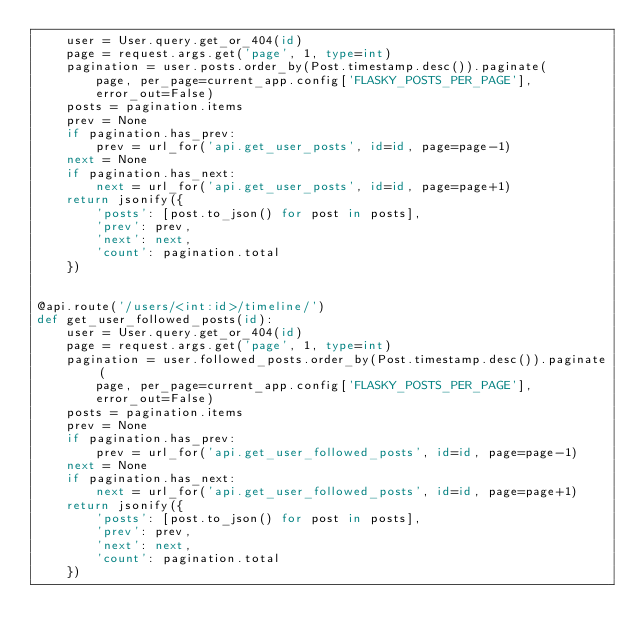<code> <loc_0><loc_0><loc_500><loc_500><_Python_>    user = User.query.get_or_404(id)
    page = request.args.get('page', 1, type=int)
    pagination = user.posts.order_by(Post.timestamp.desc()).paginate(
        page, per_page=current_app.config['FLASKY_POSTS_PER_PAGE'],
        error_out=False)
    posts = pagination.items
    prev = None
    if pagination.has_prev:
        prev = url_for('api.get_user_posts', id=id, page=page-1)
    next = None
    if pagination.has_next:
        next = url_for('api.get_user_posts', id=id, page=page+1)
    return jsonify({
        'posts': [post.to_json() for post in posts],
        'prev': prev,
        'next': next,
        'count': pagination.total
    })


@api.route('/users/<int:id>/timeline/')
def get_user_followed_posts(id):
    user = User.query.get_or_404(id)
    page = request.args.get('page', 1, type=int)
    pagination = user.followed_posts.order_by(Post.timestamp.desc()).paginate(
        page, per_page=current_app.config['FLASKY_POSTS_PER_PAGE'],
        error_out=False)
    posts = pagination.items
    prev = None
    if pagination.has_prev:
        prev = url_for('api.get_user_followed_posts', id=id, page=page-1)
    next = None
    if pagination.has_next:
        next = url_for('api.get_user_followed_posts', id=id, page=page+1)
    return jsonify({
        'posts': [post.to_json() for post in posts],
        'prev': prev,
        'next': next,
        'count': pagination.total
    })</code> 